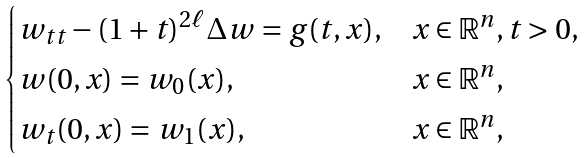Convert formula to latex. <formula><loc_0><loc_0><loc_500><loc_500>\begin{cases} w _ { t t } - ( 1 + t ) ^ { 2 \ell } \Delta w = g ( t , x ) , & x \in \mathbb { R } ^ { n } , t > 0 , \\ w ( 0 , x ) = w _ { 0 } ( x ) , & x \in \mathbb { R } ^ { n } , \\ w _ { t } ( 0 , x ) = w _ { 1 } ( x ) , & x \in \mathbb { R } ^ { n } , \end{cases}</formula> 